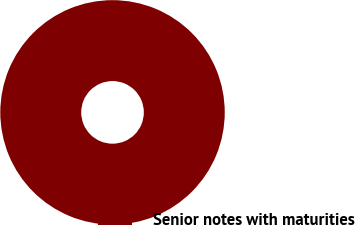Convert chart to OTSL. <chart><loc_0><loc_0><loc_500><loc_500><pie_chart><fcel>Senior notes with maturities<nl><fcel>100.0%<nl></chart> 